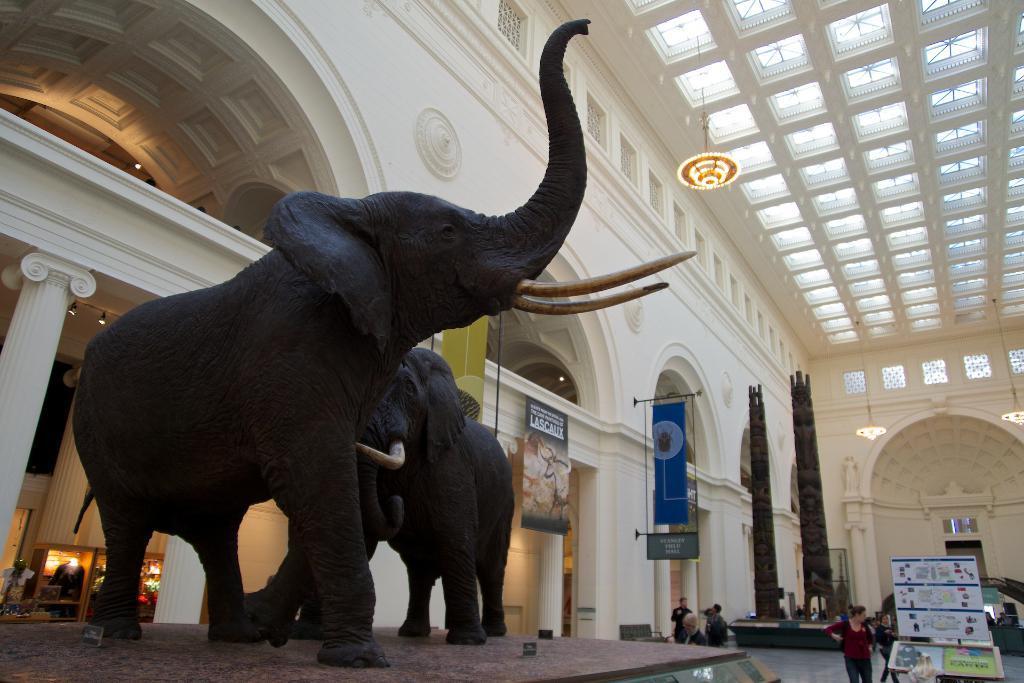Please provide a concise description of this image. In this image in the center there are statues of the elephants, there are persons standing and walking, there are boards with some text written on it, there are pillars. In the background there are persons, there are objects which are black in colour. At the top there is a chandelier and there is a wall. In the center on the left side there are lights and there is glass. 